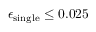<formula> <loc_0><loc_0><loc_500><loc_500>\epsilon _ { \sin g l e } \leq 0 . 0 2 5</formula> 